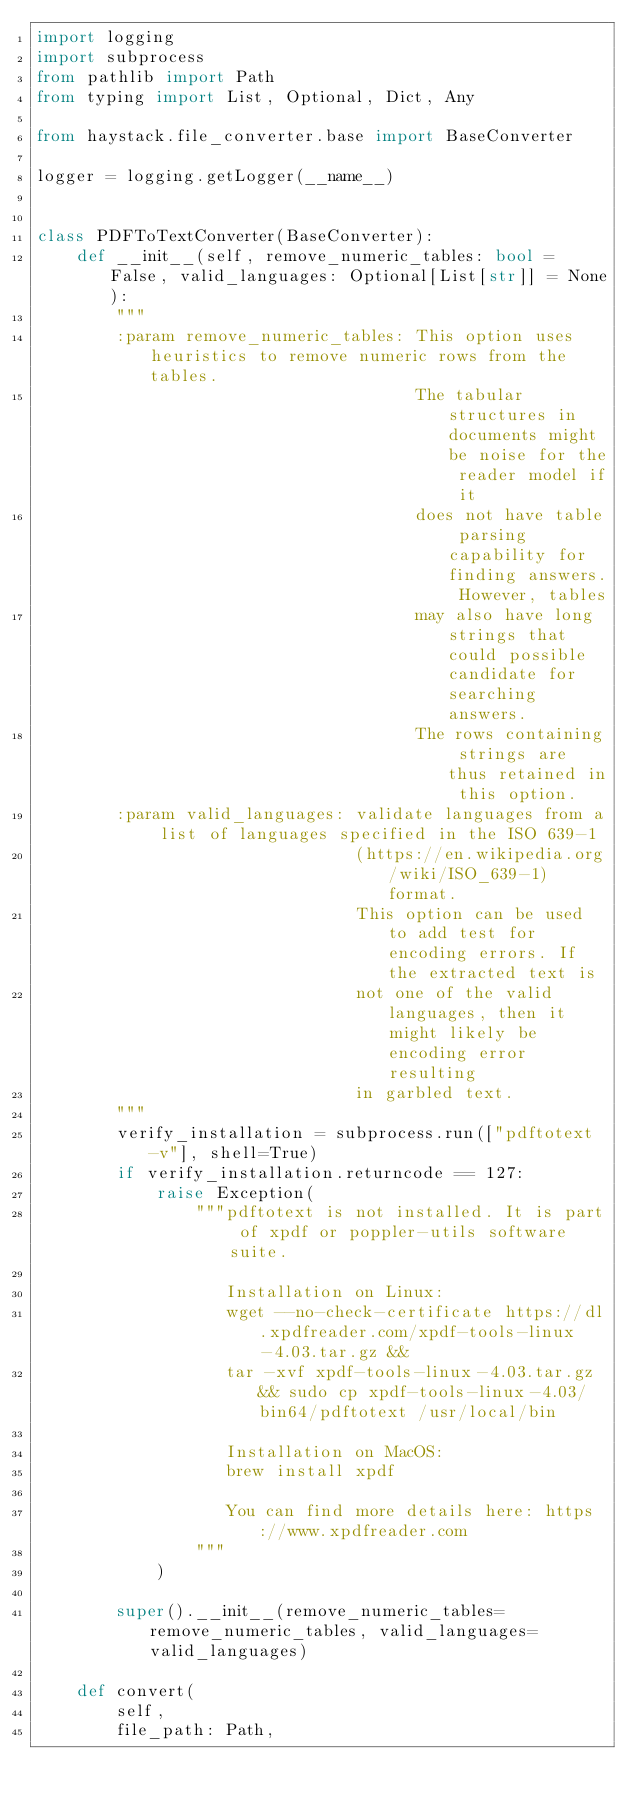<code> <loc_0><loc_0><loc_500><loc_500><_Python_>import logging
import subprocess
from pathlib import Path
from typing import List, Optional, Dict, Any

from haystack.file_converter.base import BaseConverter

logger = logging.getLogger(__name__)


class PDFToTextConverter(BaseConverter):
    def __init__(self, remove_numeric_tables: bool = False, valid_languages: Optional[List[str]] = None):
        """
        :param remove_numeric_tables: This option uses heuristics to remove numeric rows from the tables.
                                      The tabular structures in documents might be noise for the reader model if it
                                      does not have table parsing capability for finding answers. However, tables
                                      may also have long strings that could possible candidate for searching answers.
                                      The rows containing strings are thus retained in this option.
        :param valid_languages: validate languages from a list of languages specified in the ISO 639-1
                                (https://en.wikipedia.org/wiki/ISO_639-1) format.
                                This option can be used to add test for encoding errors. If the extracted text is
                                not one of the valid languages, then it might likely be encoding error resulting
                                in garbled text.
        """
        verify_installation = subprocess.run(["pdftotext -v"], shell=True)
        if verify_installation.returncode == 127:
            raise Exception(
                """pdftotext is not installed. It is part of xpdf or poppler-utils software suite.
                
                   Installation on Linux:
                   wget --no-check-certificate https://dl.xpdfreader.com/xpdf-tools-linux-4.03.tar.gz &&
                   tar -xvf xpdf-tools-linux-4.03.tar.gz && sudo cp xpdf-tools-linux-4.03/bin64/pdftotext /usr/local/bin
                   
                   Installation on MacOS:
                   brew install xpdf
                   
                   You can find more details here: https://www.xpdfreader.com
                """
            )

        super().__init__(remove_numeric_tables=remove_numeric_tables, valid_languages=valid_languages)

    def convert(
        self,
        file_path: Path,</code> 